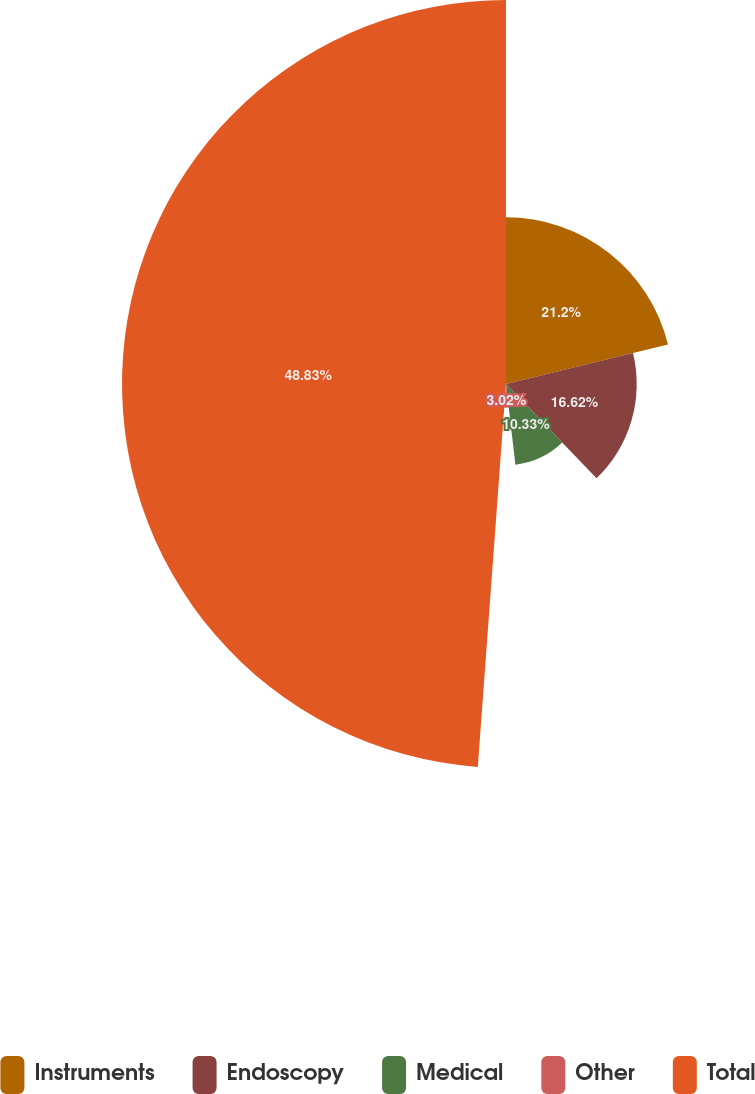Convert chart to OTSL. <chart><loc_0><loc_0><loc_500><loc_500><pie_chart><fcel>Instruments<fcel>Endoscopy<fcel>Medical<fcel>Other<fcel>Total<nl><fcel>21.2%<fcel>16.62%<fcel>10.33%<fcel>3.02%<fcel>48.83%<nl></chart> 